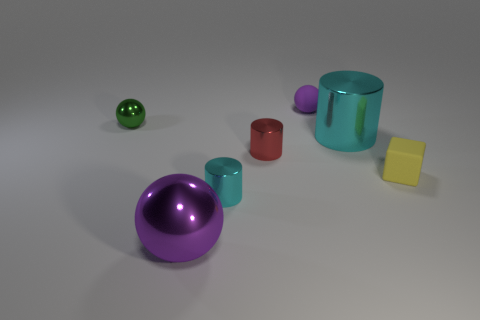Is the yellow cube made of the same material as the green ball?
Your answer should be compact. No. How many tiny cyan cylinders are the same material as the yellow block?
Give a very brief answer. 0. Does the small matte ball have the same color as the big shiny object in front of the yellow matte block?
Provide a succinct answer. Yes. Is the number of big metal objects greater than the number of matte balls?
Provide a short and direct response. Yes. The tiny rubber ball has what color?
Keep it short and to the point. Purple. Is the color of the tiny rubber object that is behind the tiny green shiny ball the same as the large sphere?
Offer a terse response. Yes. What is the material of the tiny ball that is the same color as the large metallic sphere?
Make the answer very short. Rubber. What number of large metallic balls have the same color as the small matte sphere?
Offer a very short reply. 1. Do the tiny rubber thing behind the tiny green metallic object and the green object have the same shape?
Keep it short and to the point. Yes. Are there fewer small cylinders that are in front of the small cyan metallic thing than tiny cyan cylinders right of the tiny cube?
Your answer should be compact. No. 